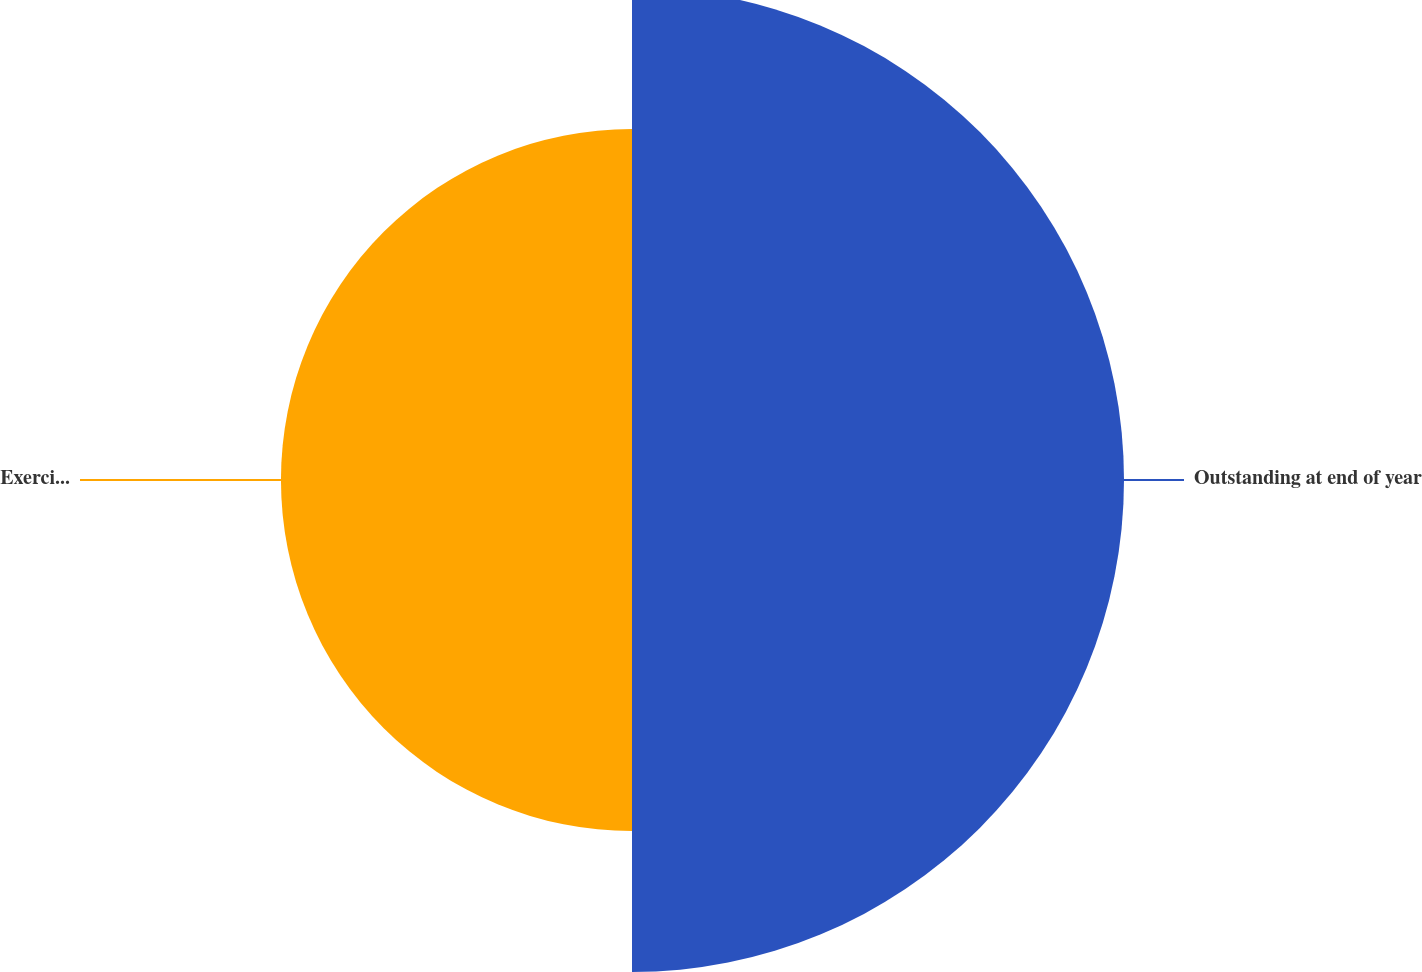Convert chart. <chart><loc_0><loc_0><loc_500><loc_500><pie_chart><fcel>Outstanding at end of year<fcel>Exercisable at end of year<nl><fcel>58.36%<fcel>41.64%<nl></chart> 